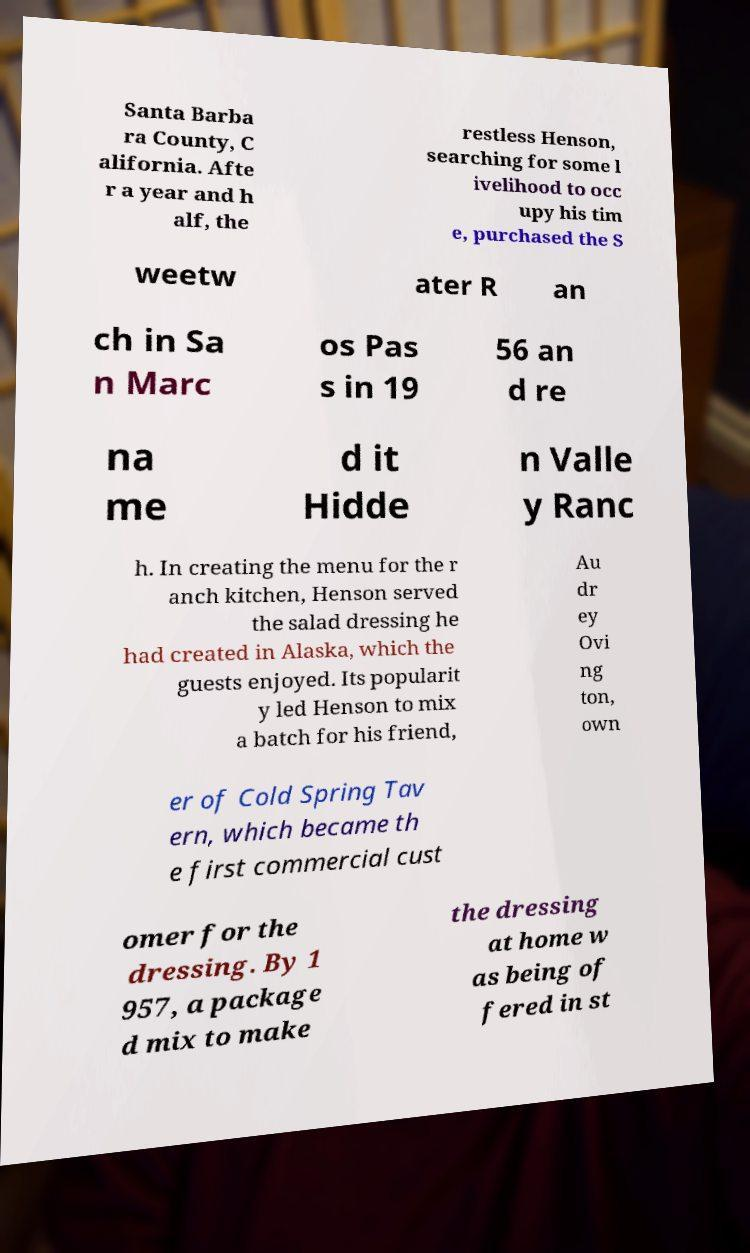For documentation purposes, I need the text within this image transcribed. Could you provide that? Santa Barba ra County, C alifornia. Afte r a year and h alf, the restless Henson, searching for some l ivelihood to occ upy his tim e, purchased the S weetw ater R an ch in Sa n Marc os Pas s in 19 56 an d re na me d it Hidde n Valle y Ranc h. In creating the menu for the r anch kitchen, Henson served the salad dressing he had created in Alaska, which the guests enjoyed. Its popularit y led Henson to mix a batch for his friend, Au dr ey Ovi ng ton, own er of Cold Spring Tav ern, which became th e first commercial cust omer for the dressing. By 1 957, a package d mix to make the dressing at home w as being of fered in st 